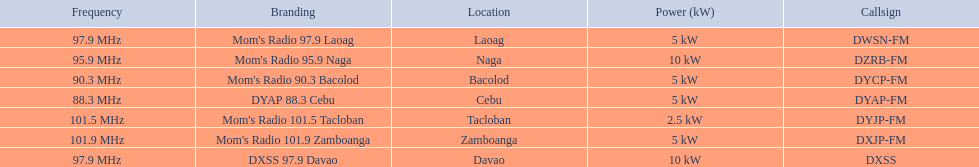Help me parse the entirety of this table. {'header': ['Frequency', 'Branding', 'Location', 'Power (kW)', 'Callsign'], 'rows': [['97.9\xa0MHz', "Mom's Radio 97.9 Laoag", 'Laoag', '5\xa0kW', 'DWSN-FM'], ['95.9\xa0MHz', "Mom's Radio 95.9 Naga", 'Naga', '10\xa0kW', 'DZRB-FM'], ['90.3\xa0MHz', "Mom's Radio 90.3 Bacolod", 'Bacolod', '5\xa0kW', 'DYCP-FM'], ['88.3\xa0MHz', 'DYAP 88.3 Cebu', 'Cebu', '5\xa0kW', 'DYAP-FM'], ['101.5\xa0MHz', "Mom's Radio 101.5 Tacloban", 'Tacloban', '2.5\xa0kW', 'DYJP-FM'], ['101.9\xa0MHz', "Mom's Radio 101.9 Zamboanga", 'Zamboanga', '5\xa0kW', 'DXJP-FM'], ['97.9\xa0MHz', 'DXSS 97.9 Davao', 'Davao', '10\xa0kW', 'DXSS']]} What is the only radio station with a frequency below 90 mhz? DYAP 88.3 Cebu. 